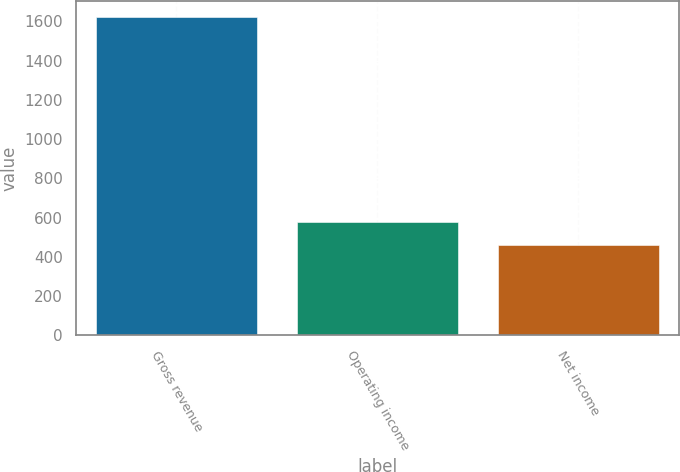<chart> <loc_0><loc_0><loc_500><loc_500><bar_chart><fcel>Gross revenue<fcel>Operating income<fcel>Net income<nl><fcel>1623<fcel>576.3<fcel>460<nl></chart> 